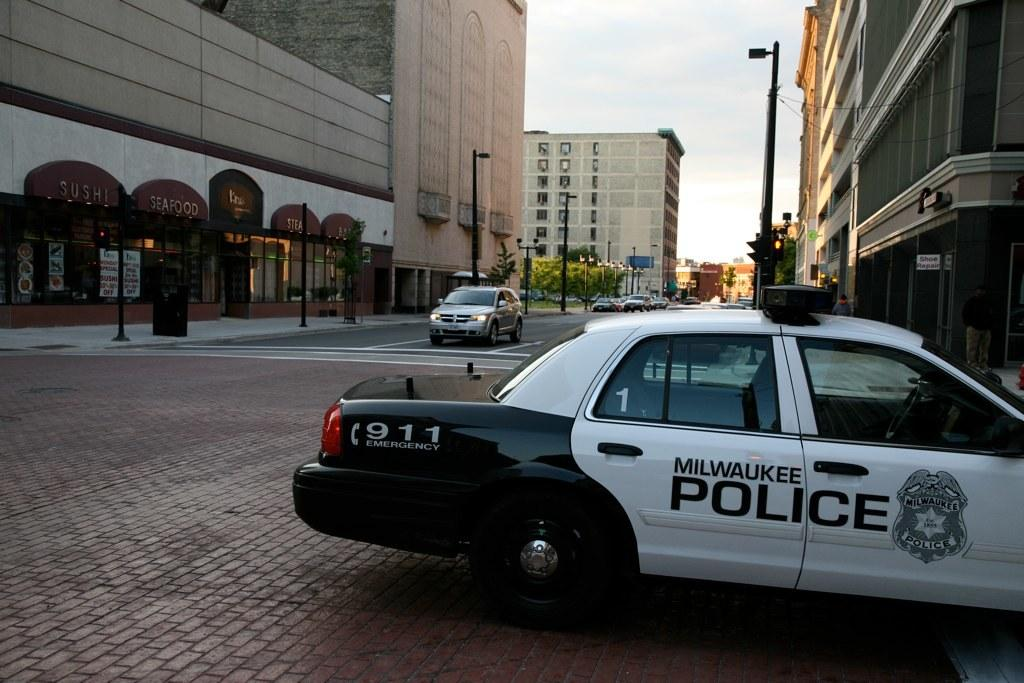What can be seen on the right side of the image? There is a car on the right side of the image. What type of structures are present in the image? There are buildings in the image. What else can be seen in the image besides the car and buildings? There are poles in the image. What might be the setting of the image? The image appears to be a roadside view. What type of steel is used to construct the sidewalk in the image? There is no sidewalk present in the image, so it is not possible to determine what type of steel might be used. 